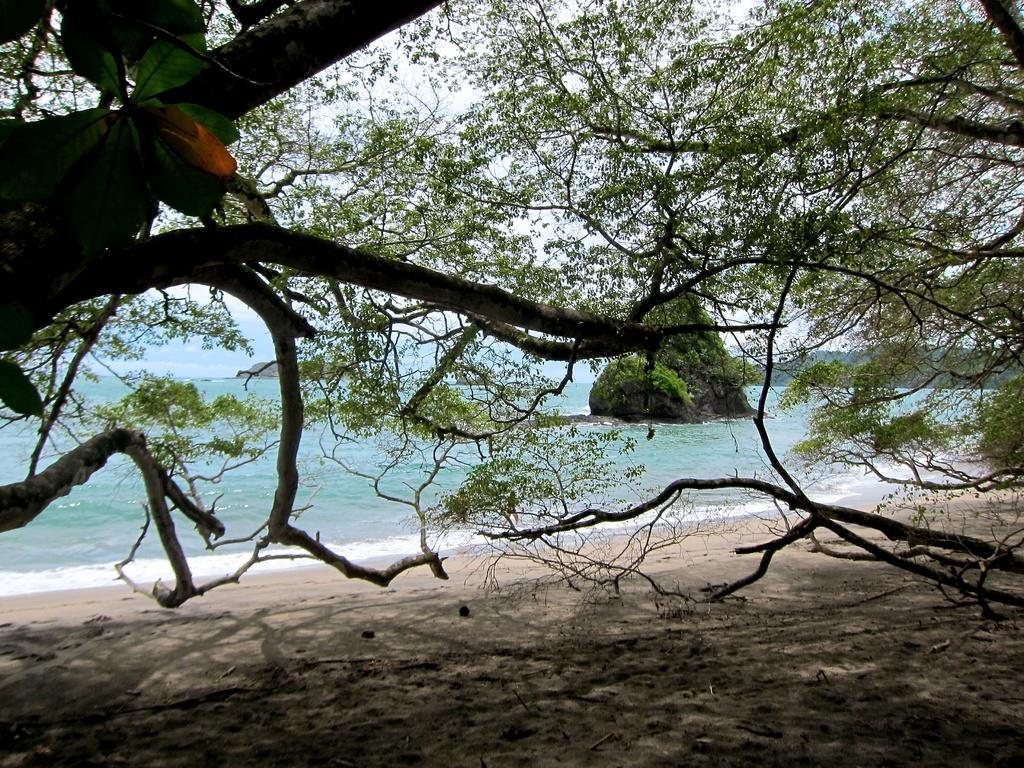What type of natural environment is shown in the image? The image appears to depict an ocean. What can be found beside the ocean? There is sand beside the ocean. Are there any plants visible in the image? Yes, there are trees on the sand. What is the big object in the ocean? There is a big rock in the ocean. What type of wheel can be seen in the image? There is no wheel present in the image. What kind of pot is placed near the trees on the sand? There is no pot present in the image. 